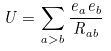Convert formula to latex. <formula><loc_0><loc_0><loc_500><loc_500>U = \sum _ { a > b } \frac { e _ { a } e _ { b } } { R _ { a b } }</formula> 